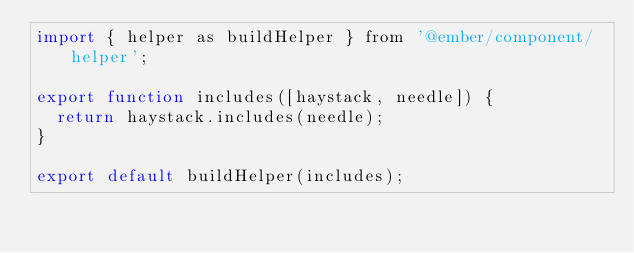<code> <loc_0><loc_0><loc_500><loc_500><_JavaScript_>import { helper as buildHelper } from '@ember/component/helper';

export function includes([haystack, needle]) {
  return haystack.includes(needle);
}

export default buildHelper(includes);
</code> 